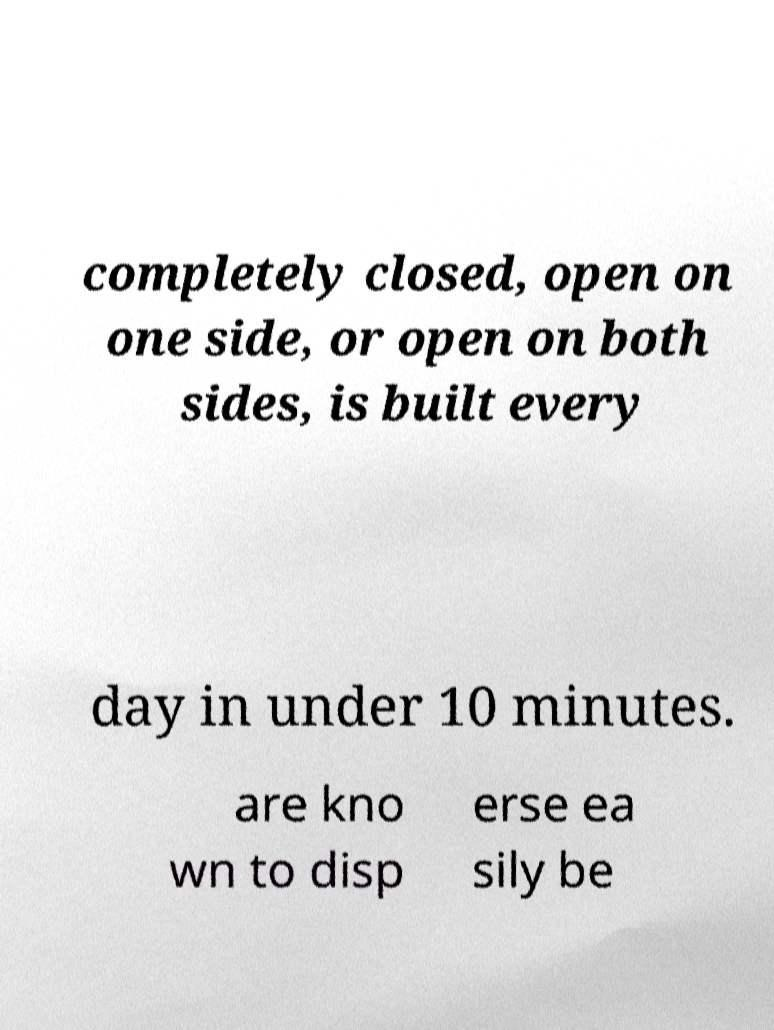Could you extract and type out the text from this image? completely closed, open on one side, or open on both sides, is built every day in under 10 minutes. are kno wn to disp erse ea sily be 